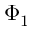<formula> <loc_0><loc_0><loc_500><loc_500>\Phi _ { 1 }</formula> 